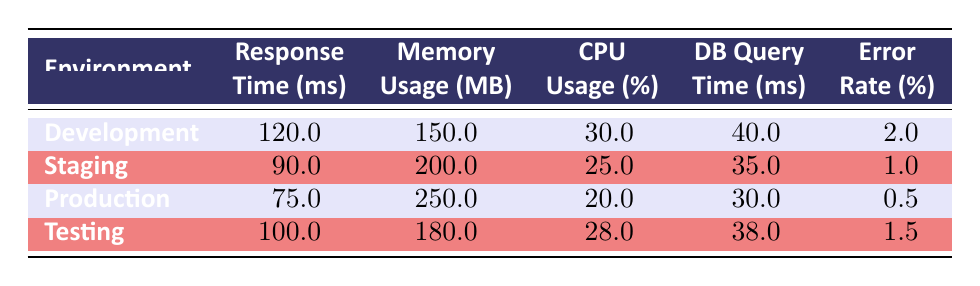What is the response time in Production? The response time for the Production environment is directly listed in the table under the 'Response Time (ms)' column corresponding to 'Production' environment row. It shows 75.0 ms.
Answer: 75.0 ms What is the memory usage for the Staging environment? Looking at the Staging row in the table, the memory usage is indicated in the 'Memory Usage (MB)' column, which shows 200.0 MB.
Answer: 200.0 MB Is the error rate in Testing higher than in Development? The testing error rate is 1.5% while the development error rate is 2%. To compare, we see that 1.5 is less than 2, therefore the error rate in Testing is not higher than in Development.
Answer: No What is the average CPU usage across all environments? To calculate the average, we first add the CPU usage values: 30 + 25 + 20 + 28 = 103. Then we divide by 4 (the number of environments), which gives us 103/4 = 25.75.
Answer: 25.75 In which environment did the database query take the longest time? The longest database query time is found in the Development row with a time of 40.0 ms, the values from all environments are compared: Development (40.0), Staging (35.0), Production (30.0), and Testing (38.0). The maximum time is 40.0 ms.
Answer: Development What is the difference in memory usage between Production and Staging? The memory usage for Production is 250.0 MB and for Staging is 200.0 MB. To find the difference, subtract the two values: 250 - 200 = 50.0 MB.
Answer: 50.0 MB Does the Production environment have a lower error rate than the Testing environment? The error rate for Production is 0.5% while for Testing it's 1.5%. Since 0.5 is less than 1.5, Production does have a lower error rate than Testing.
Answer: Yes What is the total response time for all environments? The response times are added together from the table: 120 + 90 + 75 + 100 = 385.
Answer: 385 ms Which environment has the highest CPU usage? Referring to the CPU usage values in the table: Development (30.0), Staging (25.0), Production (20.0), and Testing (28.0). The maximum CPU usage is from the Development environment at 30.0%.
Answer: Development 